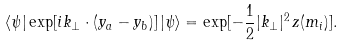Convert formula to latex. <formula><loc_0><loc_0><loc_500><loc_500>\langle \psi | \exp [ i k _ { \perp } \cdot ( y _ { a } - y _ { b } ) ] \, | \psi \rangle = \exp [ - \frac { 1 } { 2 } | k _ { \perp } | ^ { 2 } \, z ( m _ { i } ) ] .</formula> 